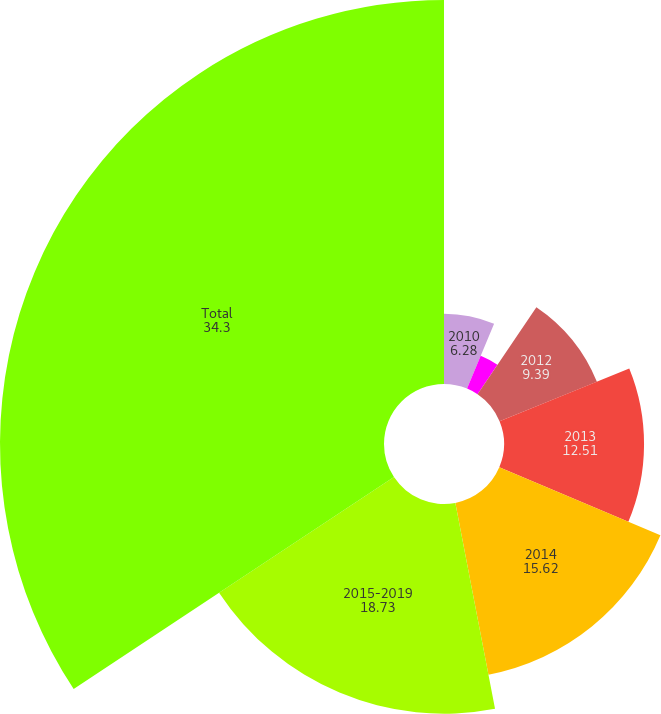Convert chart. <chart><loc_0><loc_0><loc_500><loc_500><pie_chart><fcel>2010<fcel>2011<fcel>2012<fcel>2013<fcel>2014<fcel>2015-2019<fcel>Total<nl><fcel>6.28%<fcel>3.17%<fcel>9.39%<fcel>12.51%<fcel>15.62%<fcel>18.73%<fcel>34.3%<nl></chart> 